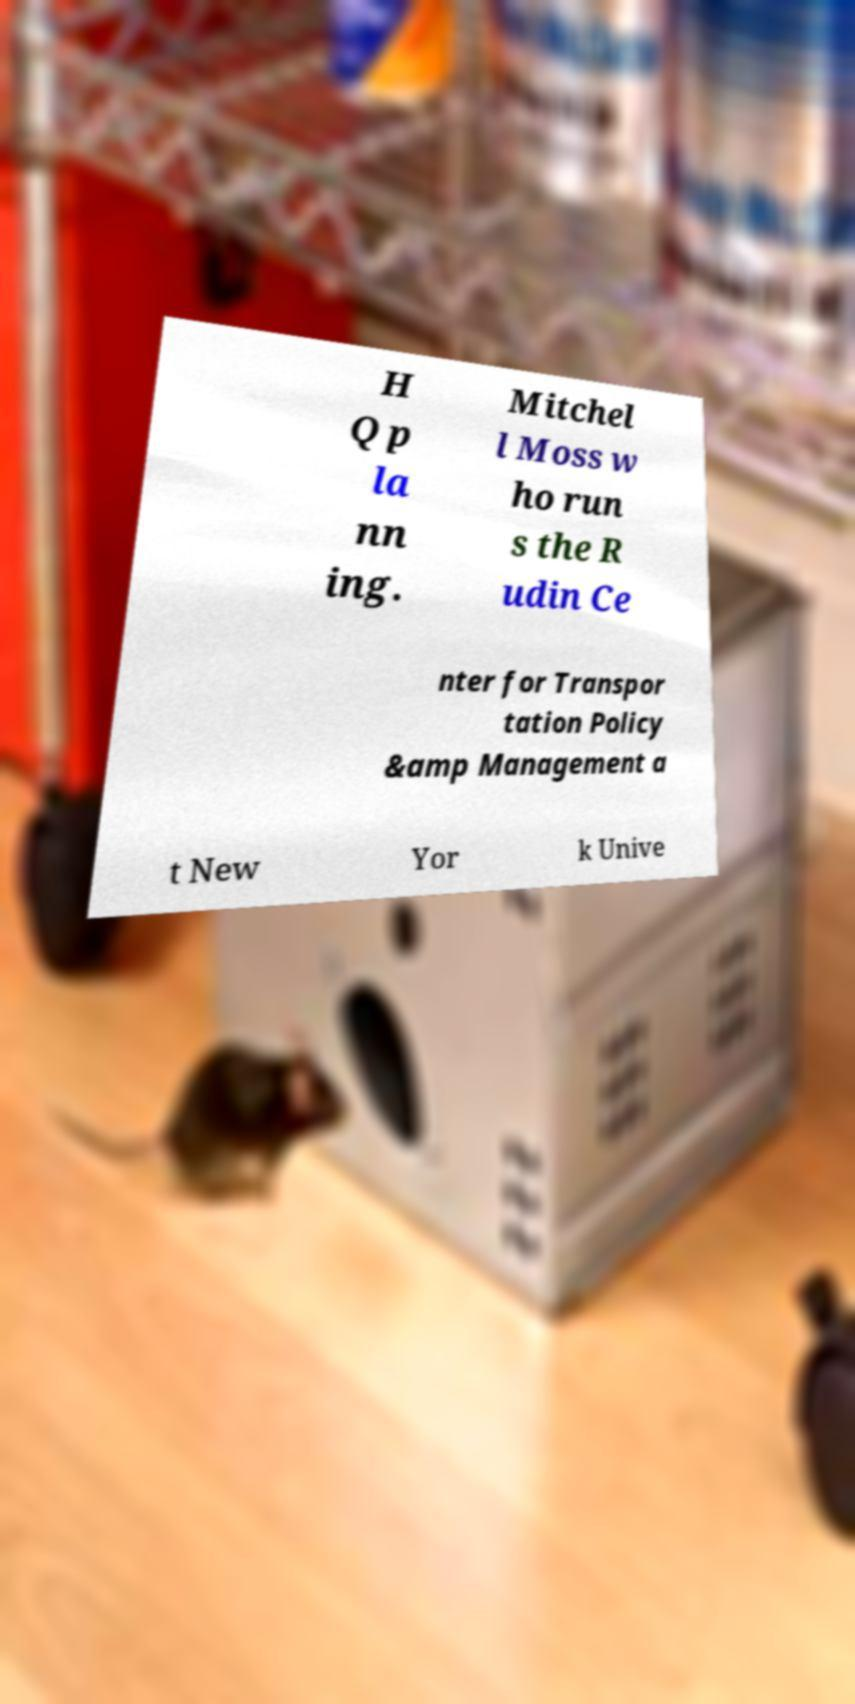Please read and relay the text visible in this image. What does it say? H Q p la nn ing. Mitchel l Moss w ho run s the R udin Ce nter for Transpor tation Policy &amp Management a t New Yor k Unive 